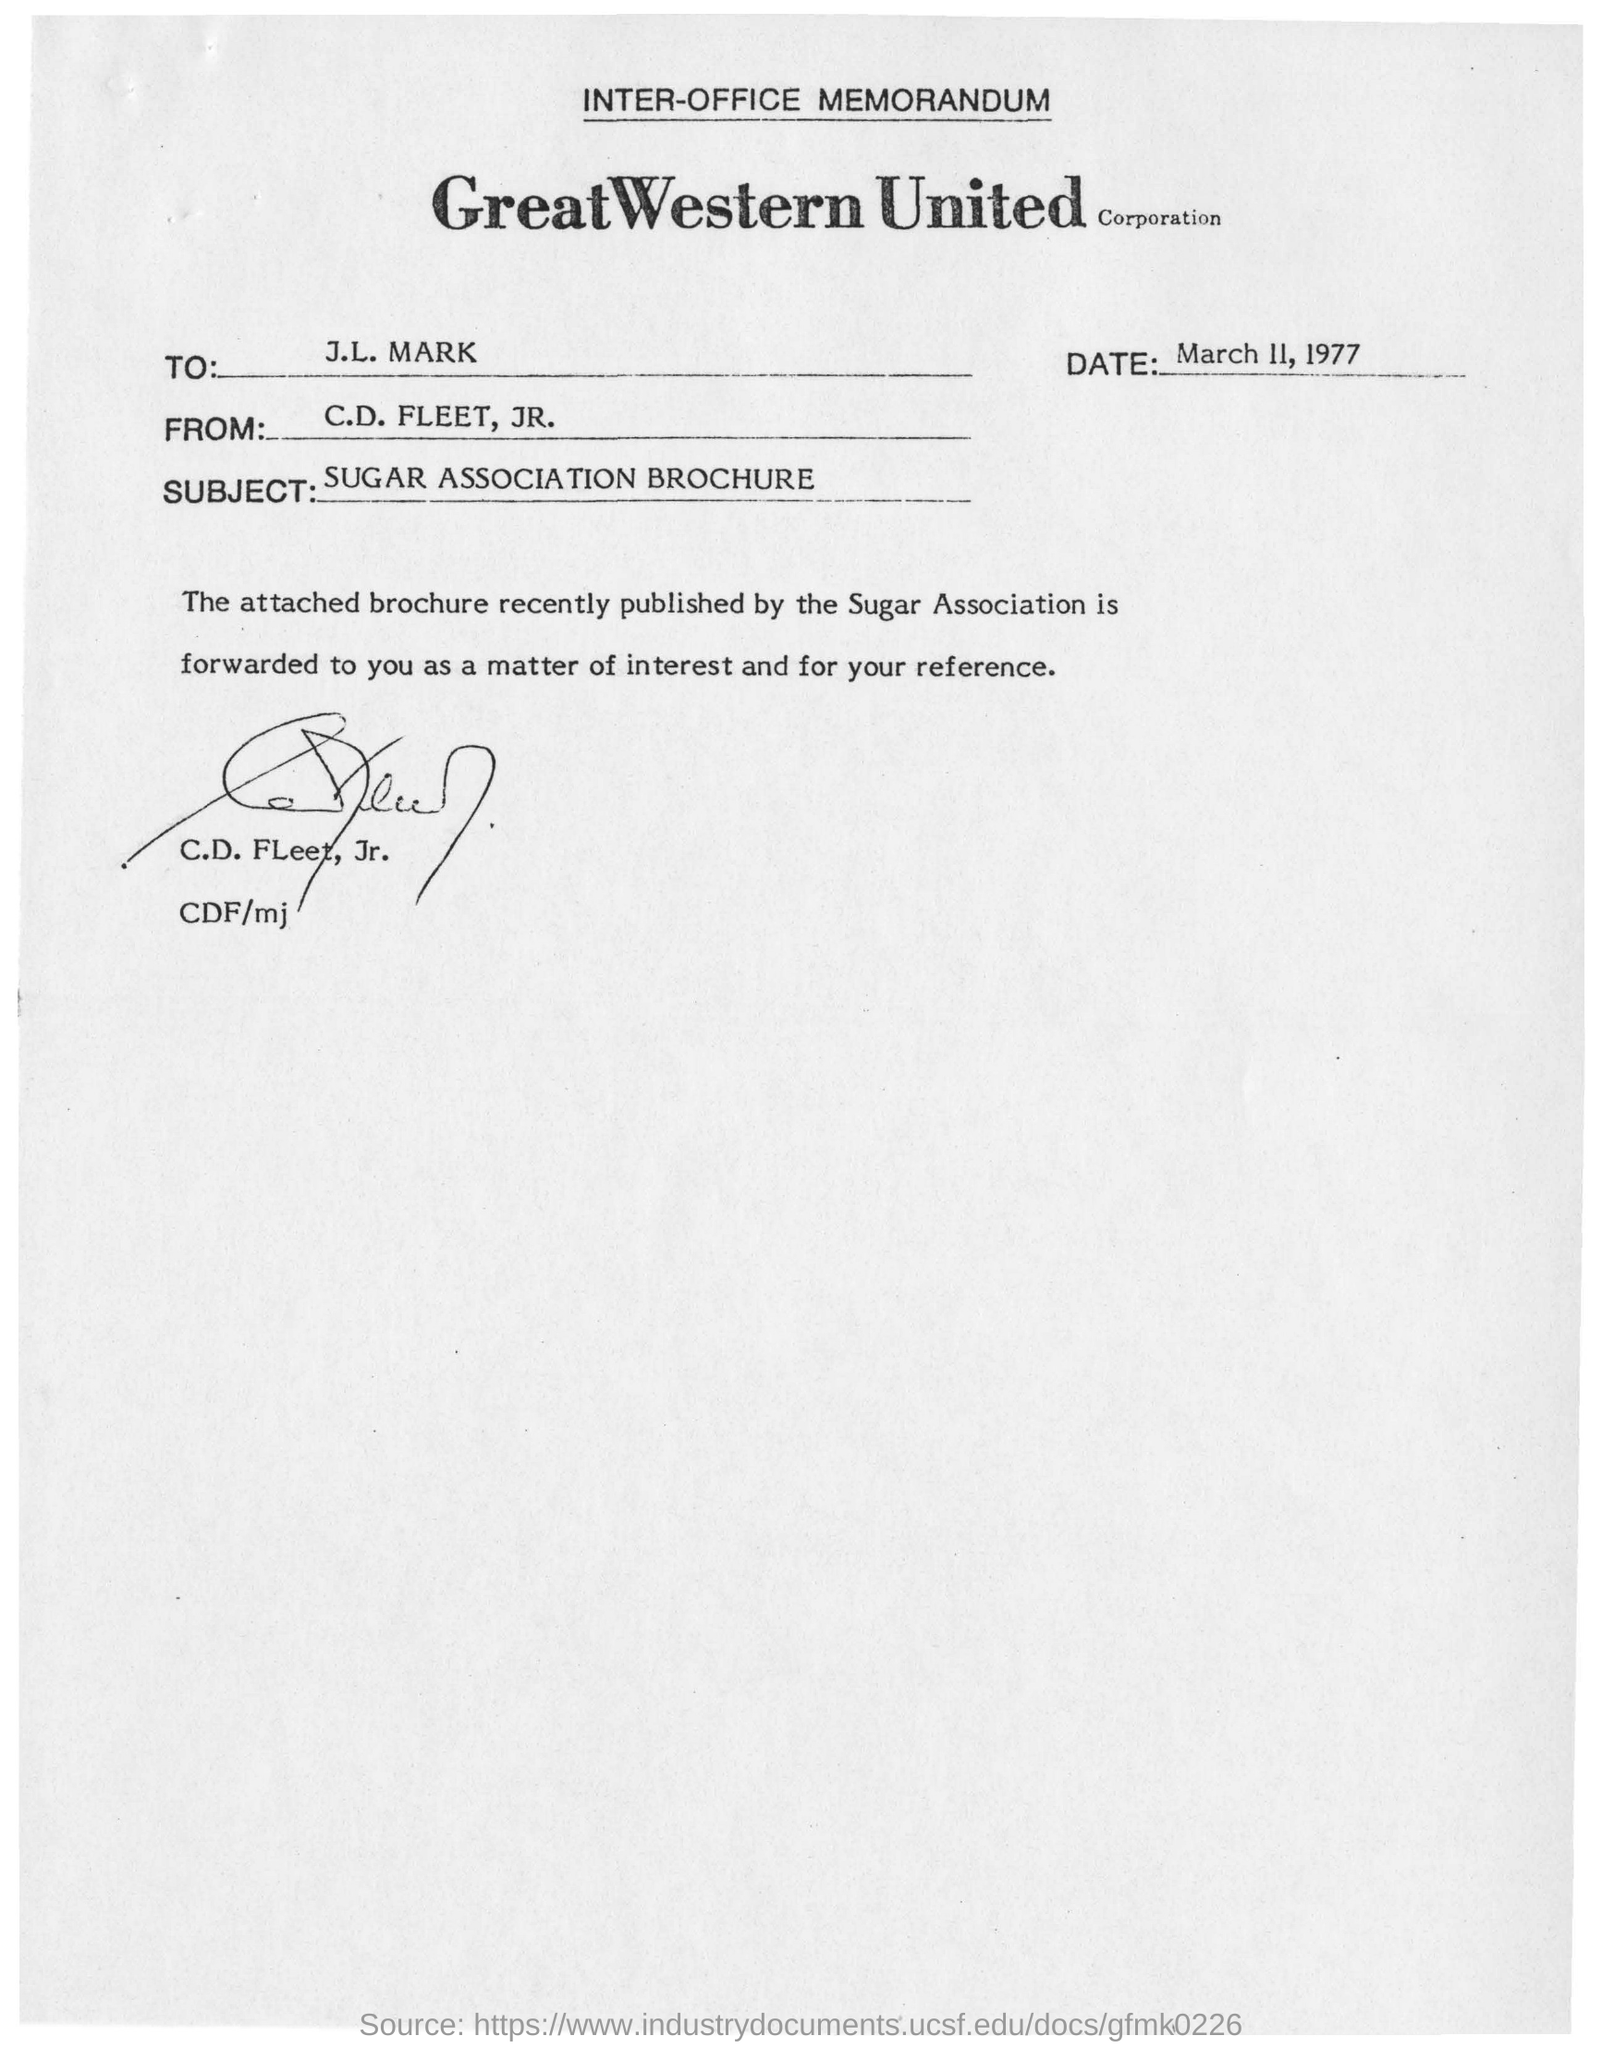To Whom is this memorandum addressed to?
Make the answer very short. J.L. Mark. When is the memorandum dated on?
Offer a very short reply. March 11, 1977. What is the subject of the memorandum?
Keep it short and to the point. SUGAR ASSOCIATION BROCHURE. 